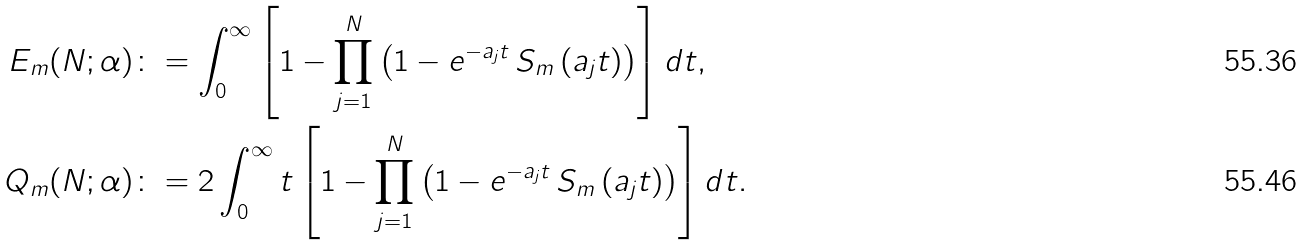Convert formula to latex. <formula><loc_0><loc_0><loc_500><loc_500>E _ { m } ( N ; \alpha ) \colon & = \int _ { 0 } ^ { \infty } \left [ 1 - \prod _ { j = 1 } ^ { N } \left ( 1 - e ^ { - a _ { j } t } \, S _ { m } \left ( a _ { j } t \right ) \right ) \right ] d t , \\ Q _ { m } ( N ; \alpha ) \colon & = 2 \int _ { 0 } ^ { \infty } t \left [ 1 - \prod _ { j = 1 } ^ { N } \left ( 1 - e ^ { - a _ { j } t } \, S _ { m } \left ( a _ { j } t \right ) \right ) \right ] d t .</formula> 